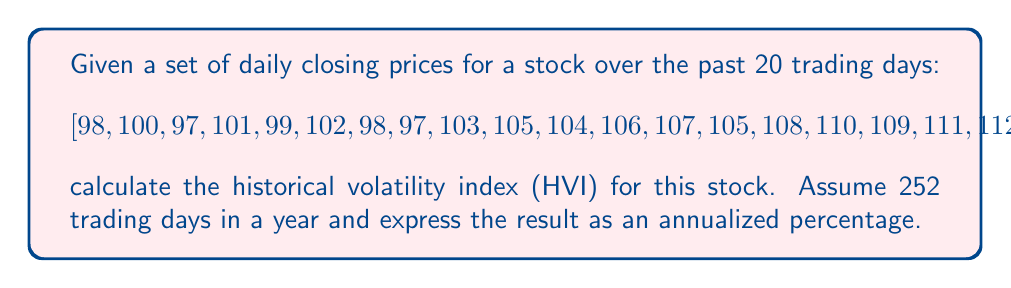Help me with this question. To calculate the historical volatility index (HVI), we'll follow these steps:

1) Calculate daily returns:
   $R_t = \ln(\frac{P_t}{P_{t-1}})$
   where $P_t$ is the price at time t.

2) Calculate the mean of daily returns:
   $\bar{R} = \frac{1}{n}\sum_{t=1}^n R_t$

3) Calculate the variance of daily returns:
   $\sigma^2 = \frac{1}{n-1}\sum_{t=1}^n (R_t - \bar{R})^2$

4) Calculate the standard deviation (daily volatility):
   $\sigma = \sqrt{\sigma^2}$

5) Annualize the volatility:
   $HVI = \sigma \times \sqrt{252} \times 100\%$

Step 1: Calculate daily returns
[0.0203, -0.0305, 0.0408, -0.0198, 0.0300, -0.0396, -0.0102, 0.0606, 0.0194, -0.0095, 0.0191, 0.0094, -0.0187, 0.0284, 0.0185, -0.0091, 0.0183, 0.0090, -0.0179]

Step 2: Mean of daily returns
$\bar{R} = 0.0073$

Step 3: Variance of daily returns
$\sigma^2 = 0.000742$

Step 4: Standard deviation (daily volatility)
$\sigma = \sqrt{0.000742} = 0.0272$

Step 5: Annualized volatility (HVI)
$HVI = 0.0272 \times \sqrt{252} \times 100\% = 43.20\%$
Answer: 43.20% 